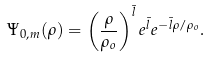Convert formula to latex. <formula><loc_0><loc_0><loc_500><loc_500>\Psi _ { 0 , m } ( \rho ) = \left ( \frac { \rho } { \rho _ { o } } \right ) ^ { \bar { l } } e ^ { \bar { l } } e ^ { - \bar { l } \rho / \rho _ { o } } .</formula> 